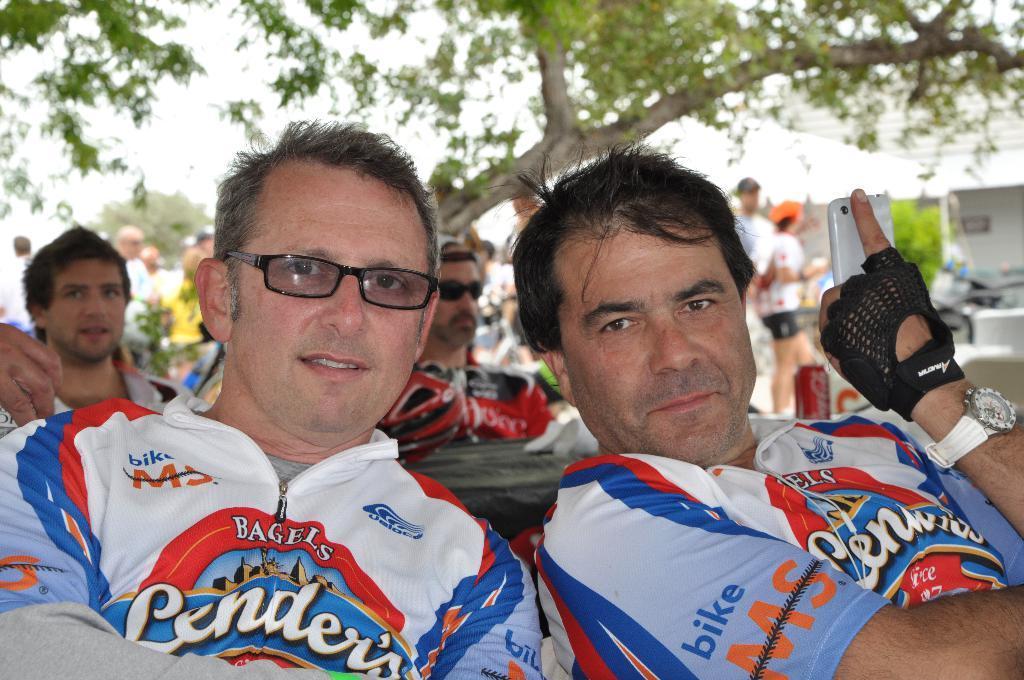Describe this image in one or two sentences. In this image, we can see a group of people. Few are sitting and standing at the background. Here we can see few people wore goggles. Right side of the image, we can see a person is holding a mobile. Background we can see trees, few plants, some items. Here there is a tin. 